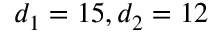Convert formula to latex. <formula><loc_0><loc_0><loc_500><loc_500>d _ { 1 } = 1 5 , d _ { 2 } = 1 2</formula> 